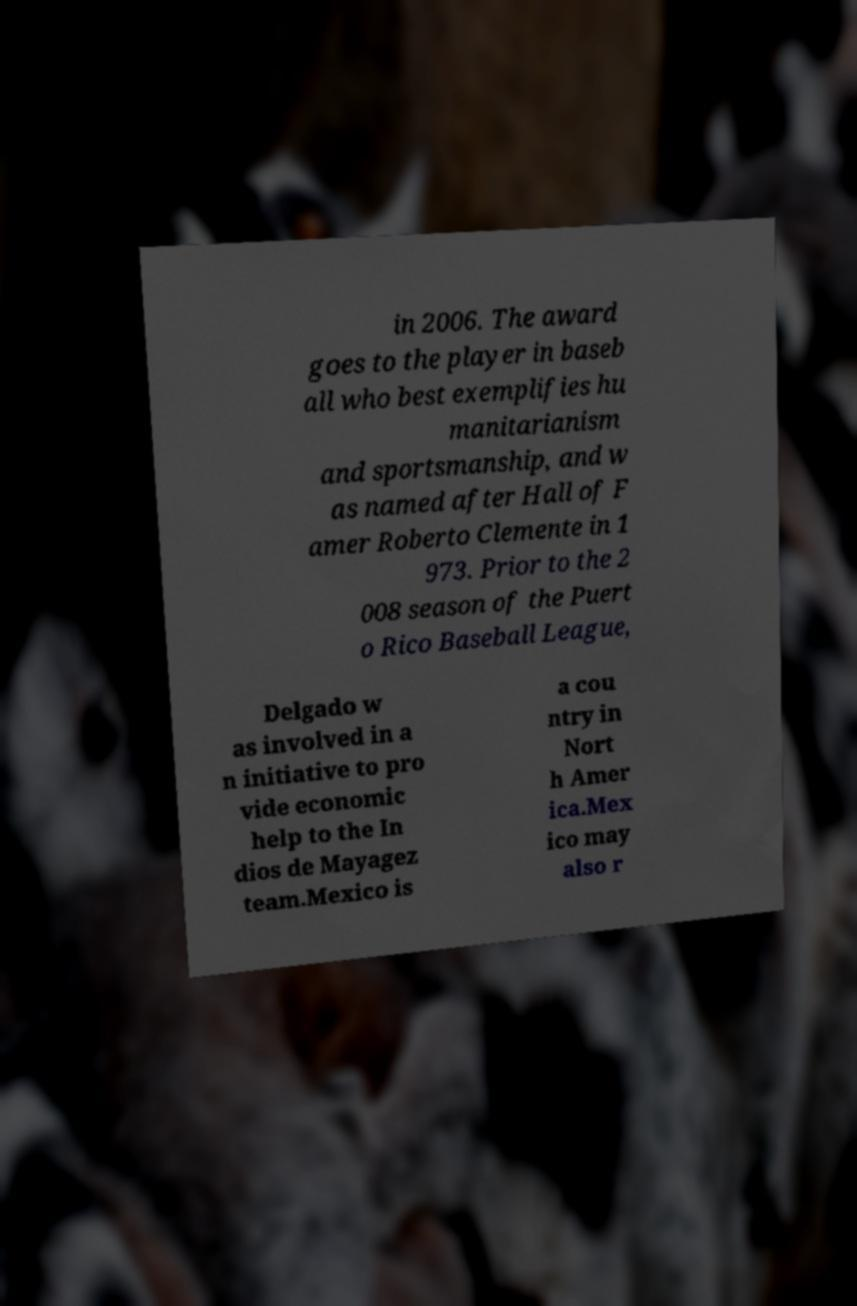I need the written content from this picture converted into text. Can you do that? in 2006. The award goes to the player in baseb all who best exemplifies hu manitarianism and sportsmanship, and w as named after Hall of F amer Roberto Clemente in 1 973. Prior to the 2 008 season of the Puert o Rico Baseball League, Delgado w as involved in a n initiative to pro vide economic help to the In dios de Mayagez team.Mexico is a cou ntry in Nort h Amer ica.Mex ico may also r 